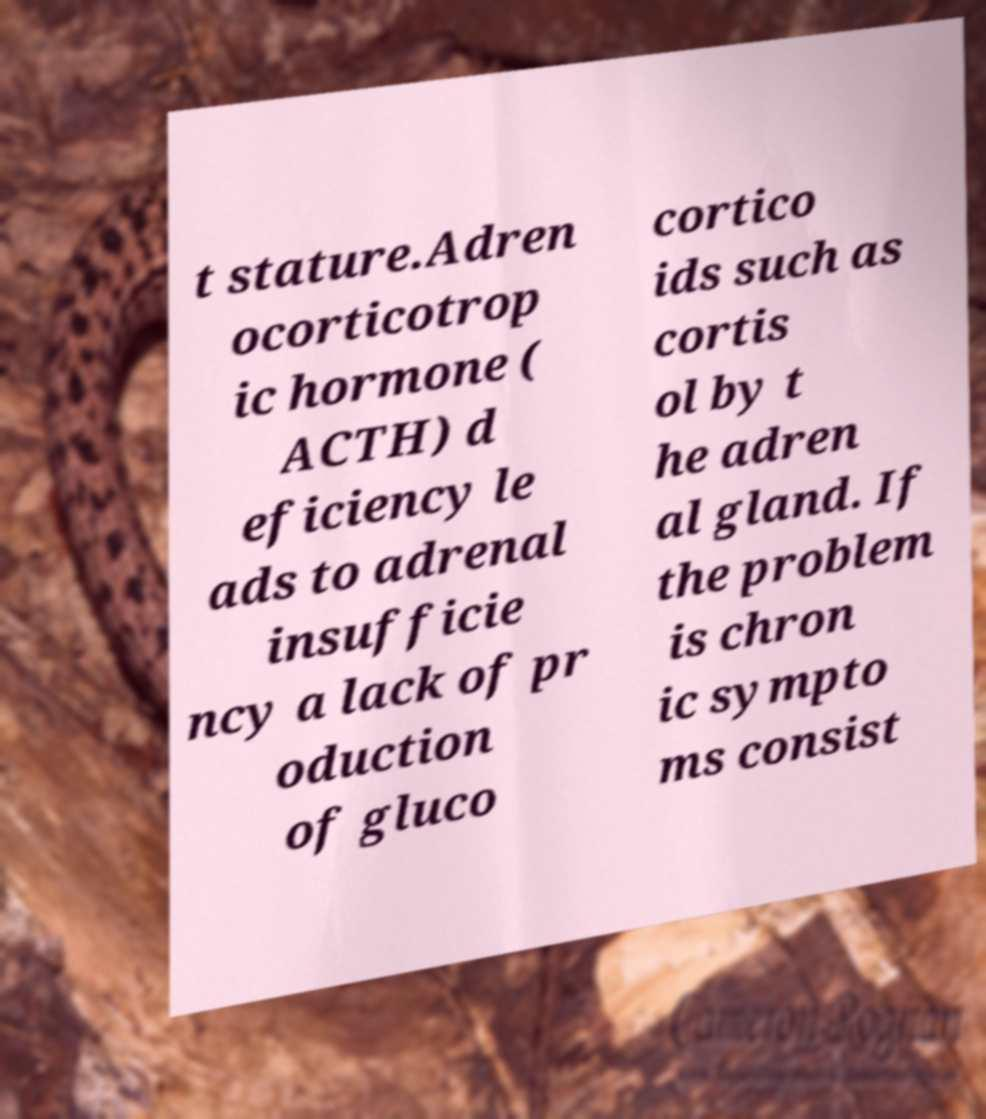There's text embedded in this image that I need extracted. Can you transcribe it verbatim? t stature.Adren ocorticotrop ic hormone ( ACTH) d eficiency le ads to adrenal insufficie ncy a lack of pr oduction of gluco cortico ids such as cortis ol by t he adren al gland. If the problem is chron ic sympto ms consist 